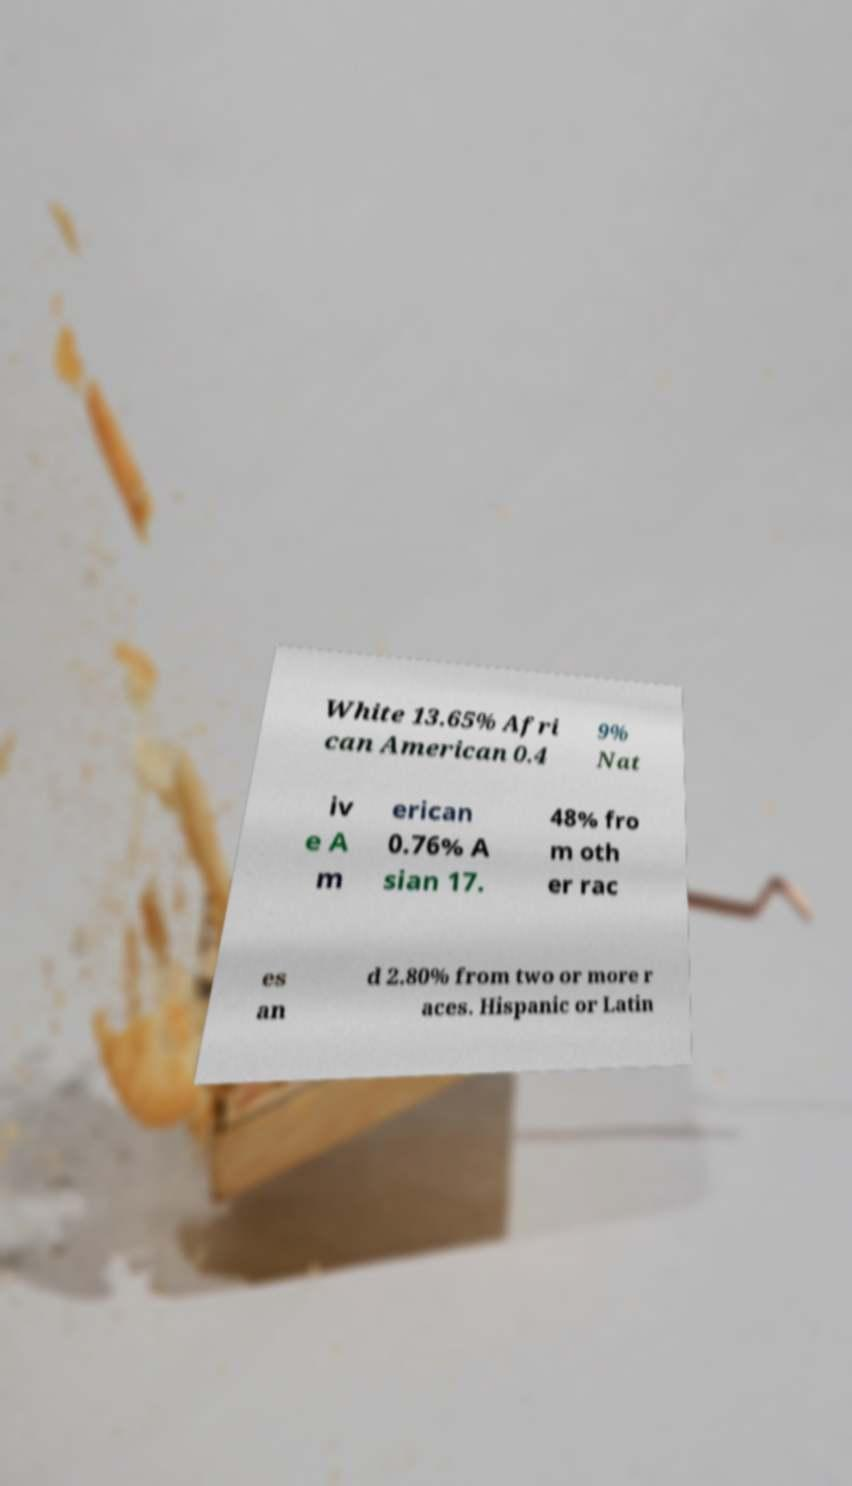Can you read and provide the text displayed in the image?This photo seems to have some interesting text. Can you extract and type it out for me? White 13.65% Afri can American 0.4 9% Nat iv e A m erican 0.76% A sian 17. 48% fro m oth er rac es an d 2.80% from two or more r aces. Hispanic or Latin 